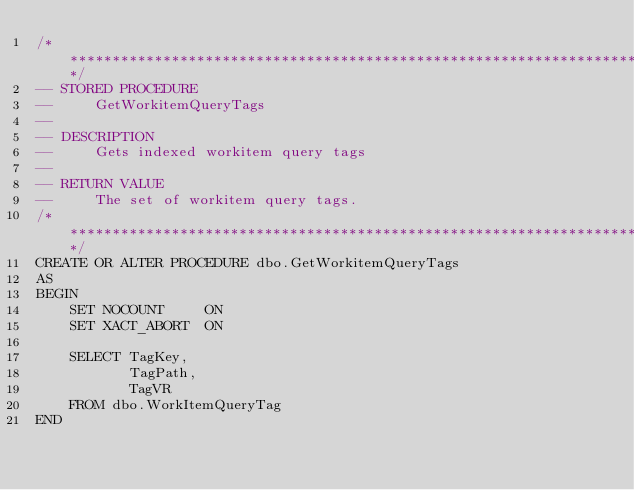<code> <loc_0><loc_0><loc_500><loc_500><_SQL_>/***************************************************************************************/
-- STORED PROCEDURE
--     GetWorkitemQueryTags
--
-- DESCRIPTION
--     Gets indexed workitem query tags
--
-- RETURN VALUE
--     The set of workitem query tags.
/***************************************************************************************/
CREATE OR ALTER PROCEDURE dbo.GetWorkitemQueryTags
AS
BEGIN
    SET NOCOUNT     ON
    SET XACT_ABORT  ON

    SELECT TagKey,
           TagPath,
           TagVR
    FROM dbo.WorkItemQueryTag
END
</code> 